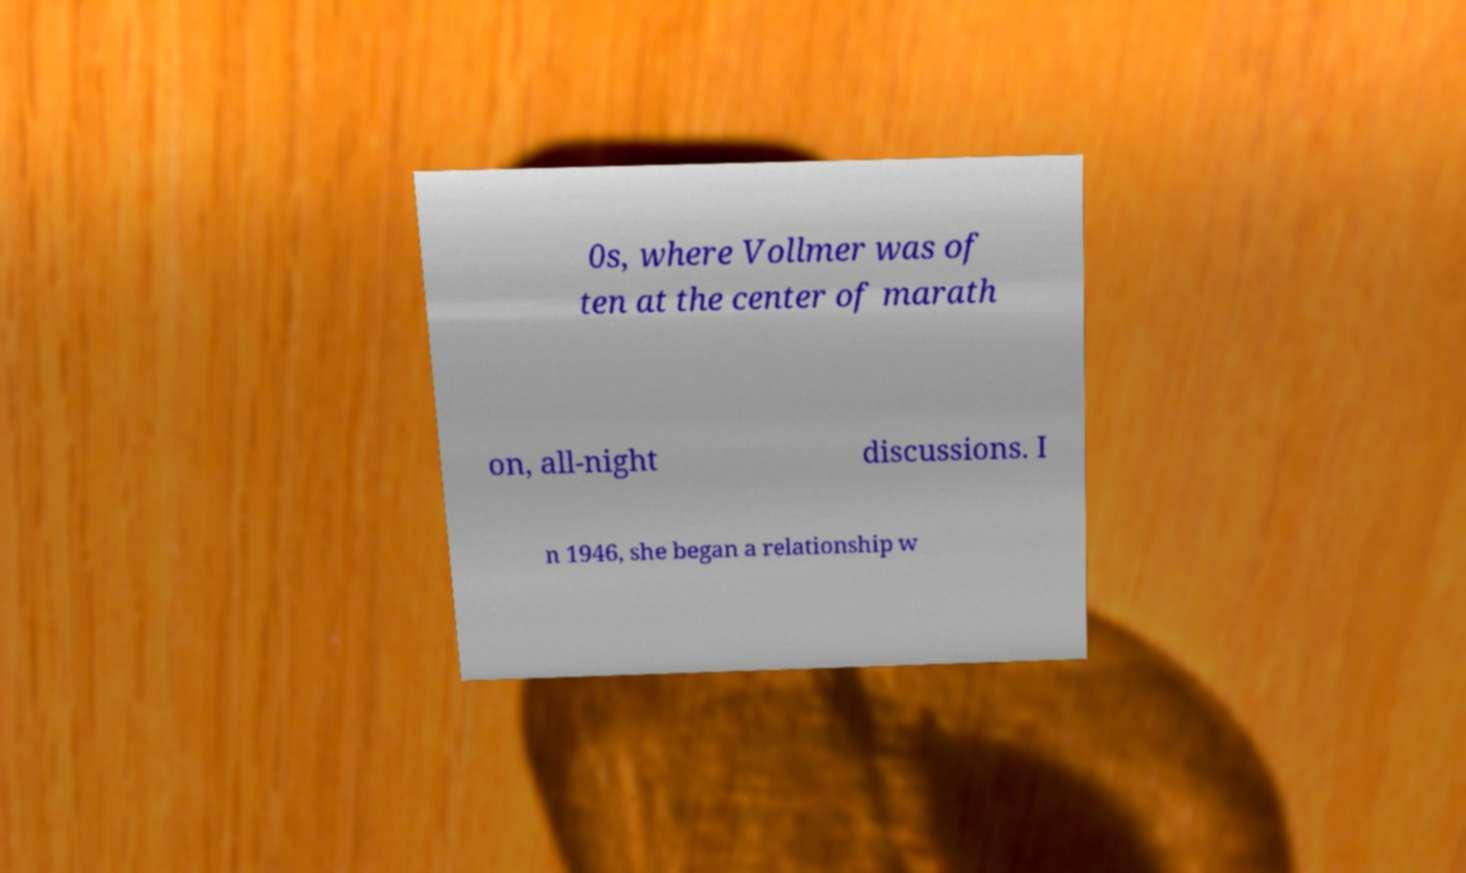I need the written content from this picture converted into text. Can you do that? 0s, where Vollmer was of ten at the center of marath on, all-night discussions. I n 1946, she began a relationship w 